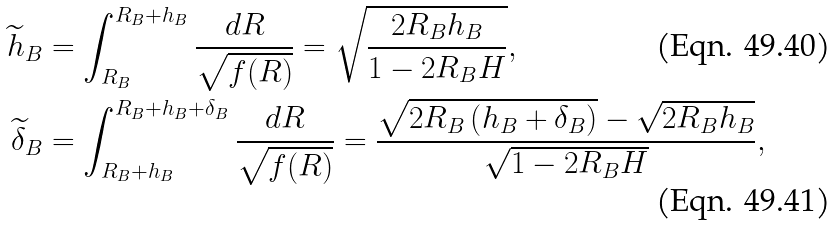Convert formula to latex. <formula><loc_0><loc_0><loc_500><loc_500>\widetilde { h } _ { B } & = \int _ { R _ { B } } ^ { R _ { B } + h _ { B } } \frac { d R } { \sqrt { f ( R ) } } = \sqrt { \frac { 2 R _ { B } h _ { B } } { 1 - 2 R _ { B } H } } , \\ \widetilde { \delta } _ { B } & = \int _ { R _ { B } + h _ { B } } ^ { R _ { B } + h _ { B } + \delta _ { B } } \frac { d R } { \sqrt { f ( R ) } } = \frac { \sqrt { 2 R _ { B } \left ( h _ { B } + \delta _ { B } \right ) } - \sqrt { 2 R _ { B } h _ { B } } } { \sqrt { 1 - 2 R _ { B } H } } ,</formula> 